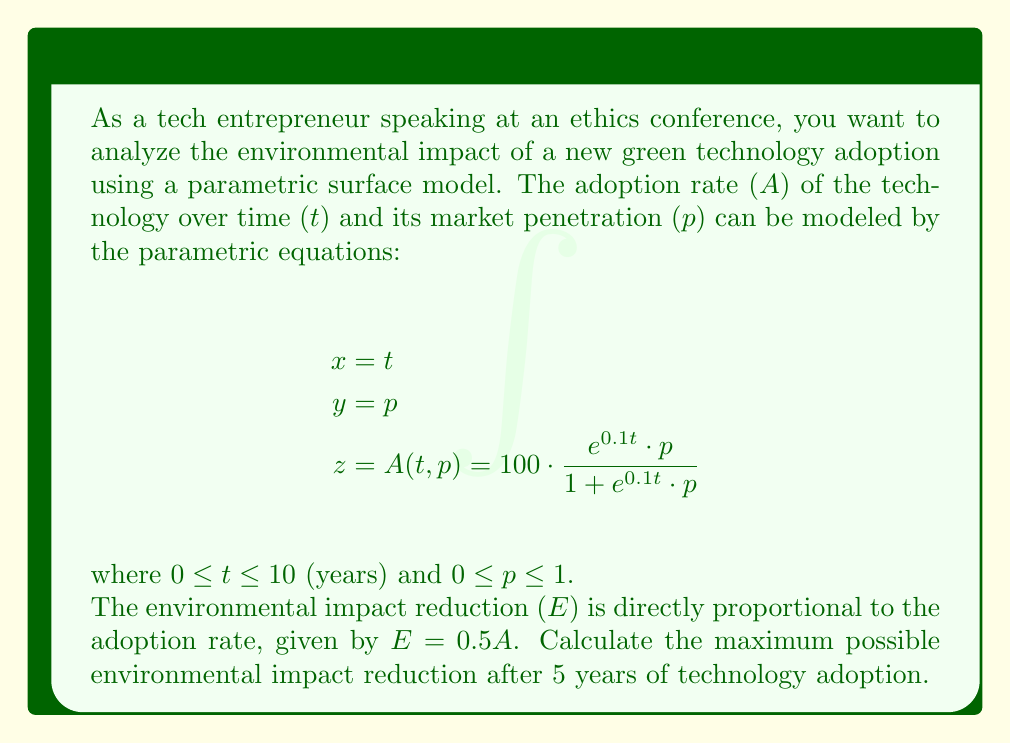What is the answer to this math problem? To solve this problem, we need to follow these steps:

1) First, we need to find the maximum adoption rate after 5 years. This occurs when the market penetration (p) is at its maximum, which is 1.

2) We substitute the values into the parametric equation for z (adoption rate):

   $$A(5,1) = 100 \cdot \frac{e^{0.1 \cdot 5} \cdot 1}{1 + e^{0.1 \cdot 5} \cdot 1}$$

3) Let's calculate this step-by-step:
   
   $$e^{0.1 \cdot 5} = e^{0.5} \approx 1.6487$$

   $$A(5,1) = 100 \cdot \frac{1.6487}{1 + 1.6487} = 100 \cdot \frac{1.6487}{2.6487}$$

   $$A(5,1) = 100 \cdot 0.6225 = 62.25$$

4) Now that we have the maximum adoption rate, we can calculate the environmental impact reduction:

   $$E = 0.5A = 0.5 \cdot 62.25 = 31.125$$

Therefore, the maximum possible environmental impact reduction after 5 years is 31.125 units.
Answer: 31.125 units 